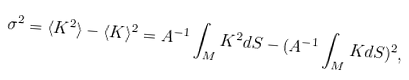<formula> <loc_0><loc_0><loc_500><loc_500>\sigma ^ { 2 } = \langle K ^ { 2 } \rangle - \langle K \rangle ^ { 2 } = A ^ { - 1 } \int _ { M } K ^ { 2 } d S - ( A ^ { - 1 } \int _ { M } K d S ) ^ { 2 } ,</formula> 